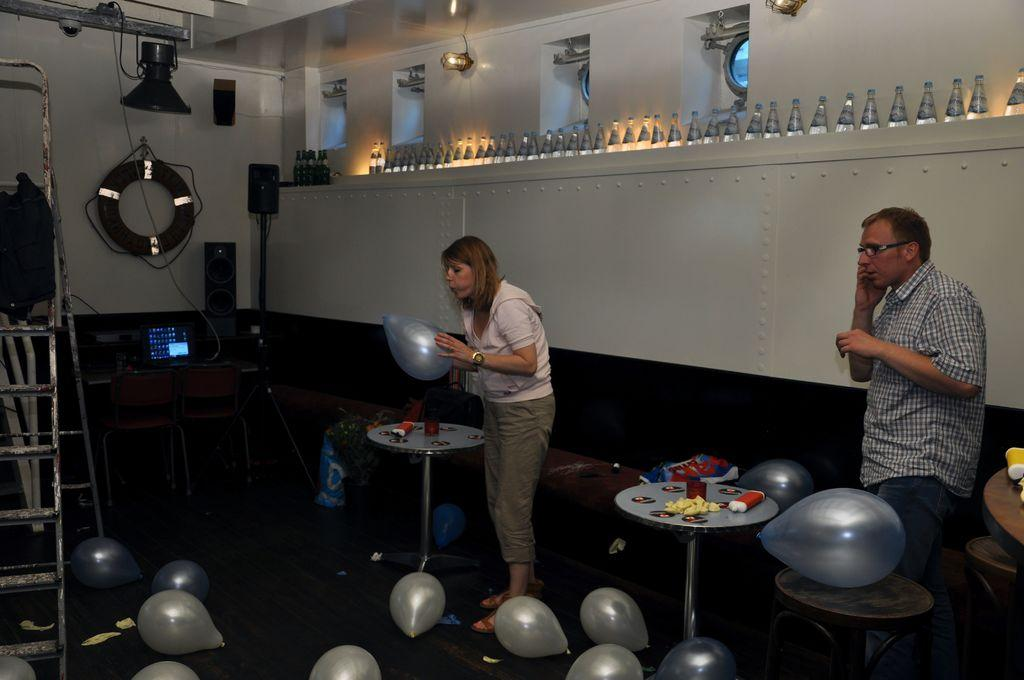What is the woman in the image holding? The woman is holding a balloon. What is the man in the image doing? The man is speaking on a mobile phone. What object can be seen on the table in the image? The table has balloons on it. How many balloons are visible in the image? There are balloons on the table, in the woman's hand, and on the floor, so there are at least three balloons visible. What additional object is present in the image? There is a ladder in the image. What type of key is the goat using to unlock the door in the image? There is no goat or door present in the image, so it is not possible to answer that question. 